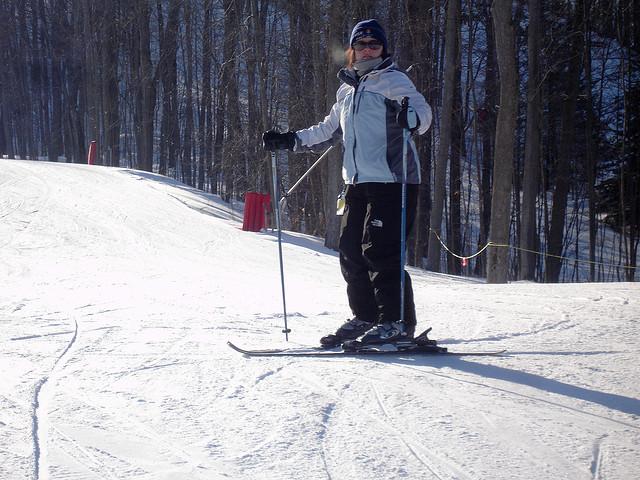How many ski poles does the person have?
Answer briefly. 2. What color is the snow?
Write a very short answer. White. What is the person doing?
Concise answer only. Skiing. 